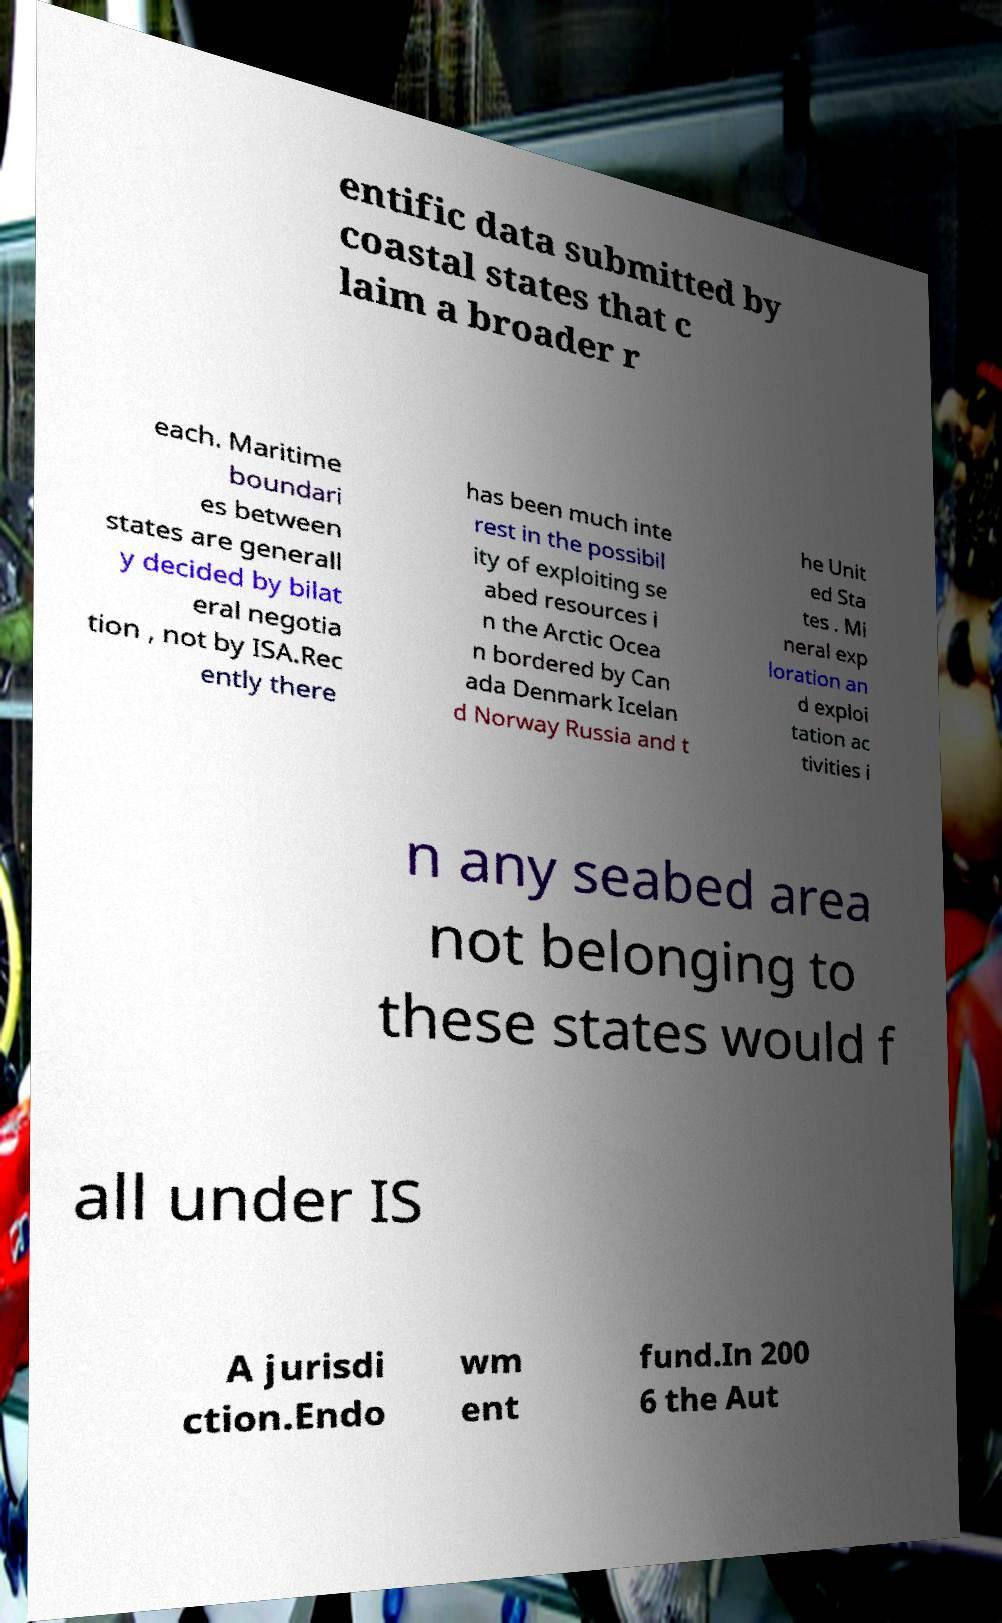What messages or text are displayed in this image? I need them in a readable, typed format. entific data submitted by coastal states that c laim a broader r each. Maritime boundari es between states are generall y decided by bilat eral negotia tion , not by ISA.Rec ently there has been much inte rest in the possibil ity of exploiting se abed resources i n the Arctic Ocea n bordered by Can ada Denmark Icelan d Norway Russia and t he Unit ed Sta tes . Mi neral exp loration an d exploi tation ac tivities i n any seabed area not belonging to these states would f all under IS A jurisdi ction.Endo wm ent fund.In 200 6 the Aut 